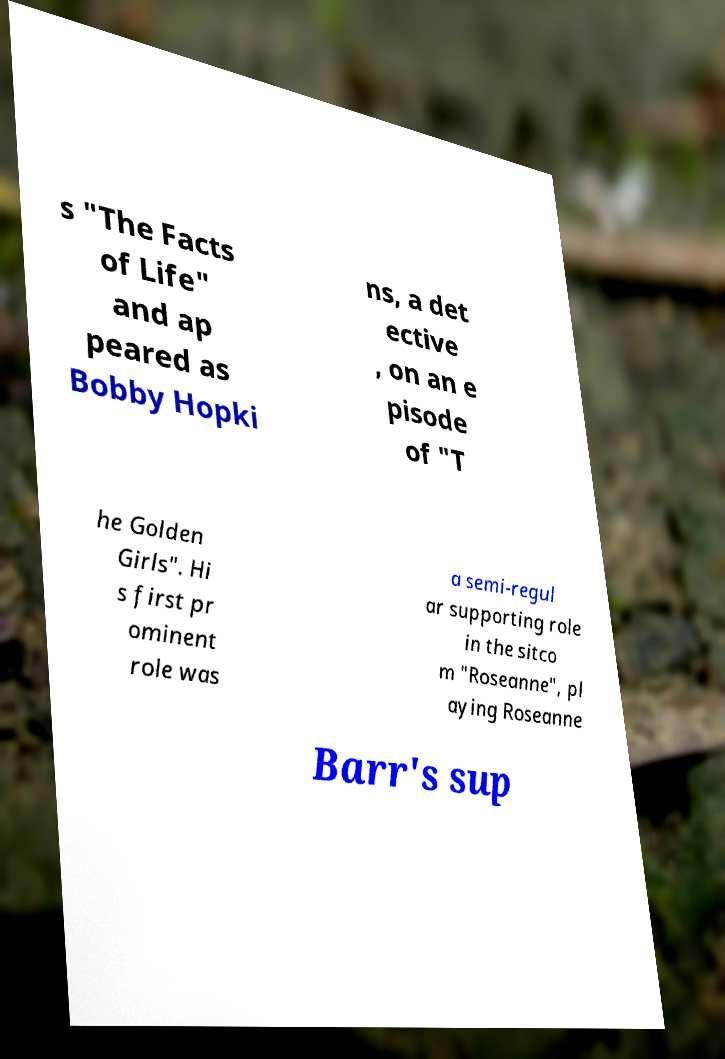Could you extract and type out the text from this image? s "The Facts of Life" and ap peared as Bobby Hopki ns, a det ective , on an e pisode of "T he Golden Girls". Hi s first pr ominent role was a semi-regul ar supporting role in the sitco m "Roseanne", pl aying Roseanne Barr's sup 